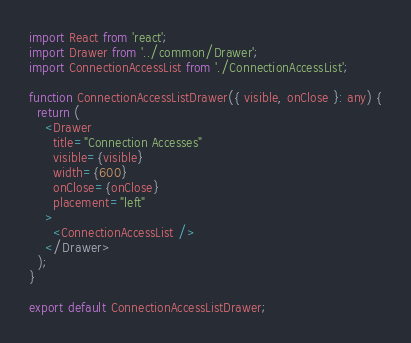<code> <loc_0><loc_0><loc_500><loc_500><_TypeScript_>import React from 'react';
import Drawer from '../common/Drawer';
import ConnectionAccessList from './ConnectionAccessList';

function ConnectionAccessListDrawer({ visible, onClose }: any) {
  return (
    <Drawer
      title="Connection Accesses"
      visible={visible}
      width={600}
      onClose={onClose}
      placement="left"
    >
      <ConnectionAccessList />
    </Drawer>
  );
}

export default ConnectionAccessListDrawer;
</code> 